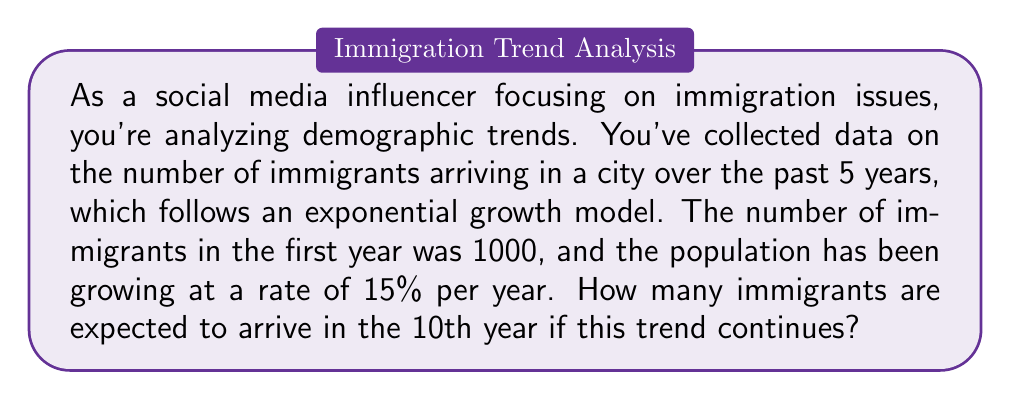Show me your answer to this math problem. Let's approach this step-by-step using the exponential growth formula:

1) The exponential growth formula is:
   $$A = P(1 + r)^t$$
   Where:
   $A$ = Final amount
   $P$ = Initial principal balance
   $r$ = Growth rate (as a decimal)
   $t$ = Time periods

2) We know:
   $P = 1000$ (initial number of immigrants)
   $r = 0.15$ (15% growth rate)
   $t = 9$ (we want the 10th year, which is 9 years after the initial year)

3) Plugging these values into the formula:
   $$A = 1000(1 + 0.15)^9$$

4) Simplify:
   $$A = 1000(1.15)^9$$

5) Calculate:
   $$A = 1000 * 3.5177 = 3517.7$$

6) Since we can't have a fractional number of immigrants, we round to the nearest whole number:
   $$A ≈ 3518$$

Therefore, approximately 3518 immigrants are expected to arrive in the 10th year if this trend continues.
Answer: 3518 immigrants 